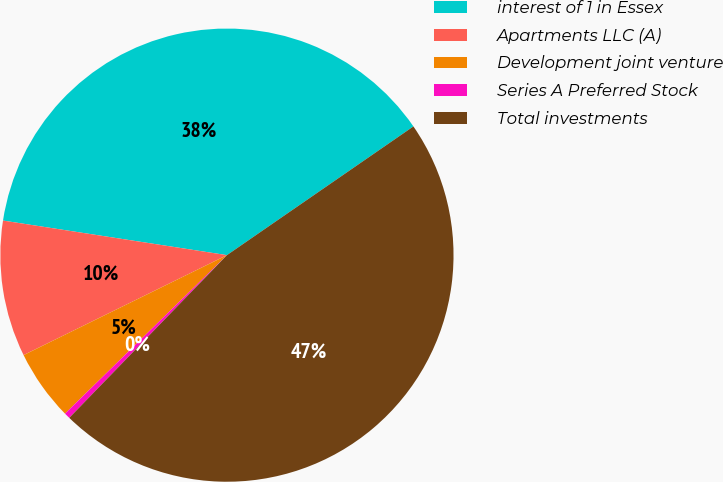Convert chart to OTSL. <chart><loc_0><loc_0><loc_500><loc_500><pie_chart><fcel>interest of 1 in Essex<fcel>Apartments LLC (A)<fcel>Development joint venture<fcel>Series A Preferred Stock<fcel>Total investments<nl><fcel>37.95%<fcel>9.71%<fcel>5.06%<fcel>0.42%<fcel>46.87%<nl></chart> 